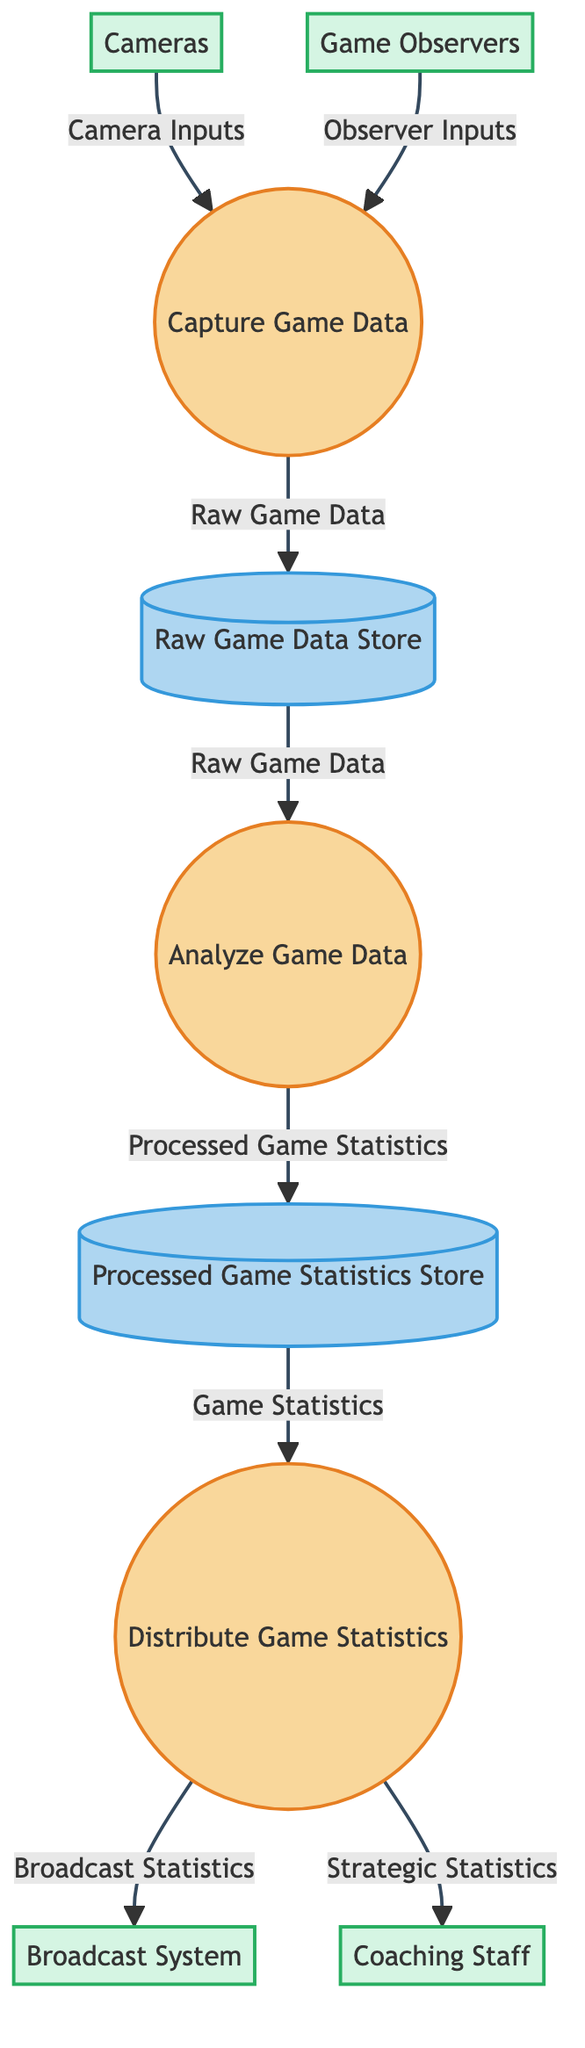What is the function of process 1? Process 1 is labeled "Capture Game Data" and its function is to collect and transmit raw data from the game.
Answer: Collect and transmit raw data from the game How many external entities are there in the diagram? There are four external entities: Cameras, Game Observers, Broadcast System, and Coaching Staff.
Answer: Four What type of data is stored in data store A? Data store A is labeled "Raw Game Data Store" and contains unprocessed game data.
Answer: Unprocessed game data Which process is responsible for distributing game statistics? Process 3 is labeled "Distribute Game Statistics" and is responsible for delivering processed game statistics to relevant stakeholders in real-time.
Answer: Distribute Game Statistics What data flows from the Process 1 to Data Store A? The data that flows from Process 1 to Data Store A is labeled "Raw Game Data".
Answer: Raw Game Data What external entity receives "Broadcast Statistics"? The Broadcast System is the external entity that receives "Broadcast Statistics".
Answer: Broadcast System Which process analyzes the raw game data? Process 2 is labeled "Analyze Game Data" and it processes the raw game data into meaningful statistics.
Answer: Analyze Game Data What is the data that flows from Data Store B to Process 3? The data flowing from Data Store B to Process 3 is labeled "Game Statistics".
Answer: Game Statistics How many processes are in the diagram? There are three processes: Capture Game Data, Analyze Game Data, and Distribute Game Statistics.
Answer: Three What types of statistics does Coaching Staff receive? The Coaching Staff receives "Strategic Statistics" for their decision-making purposes.
Answer: Strategic Statistics 